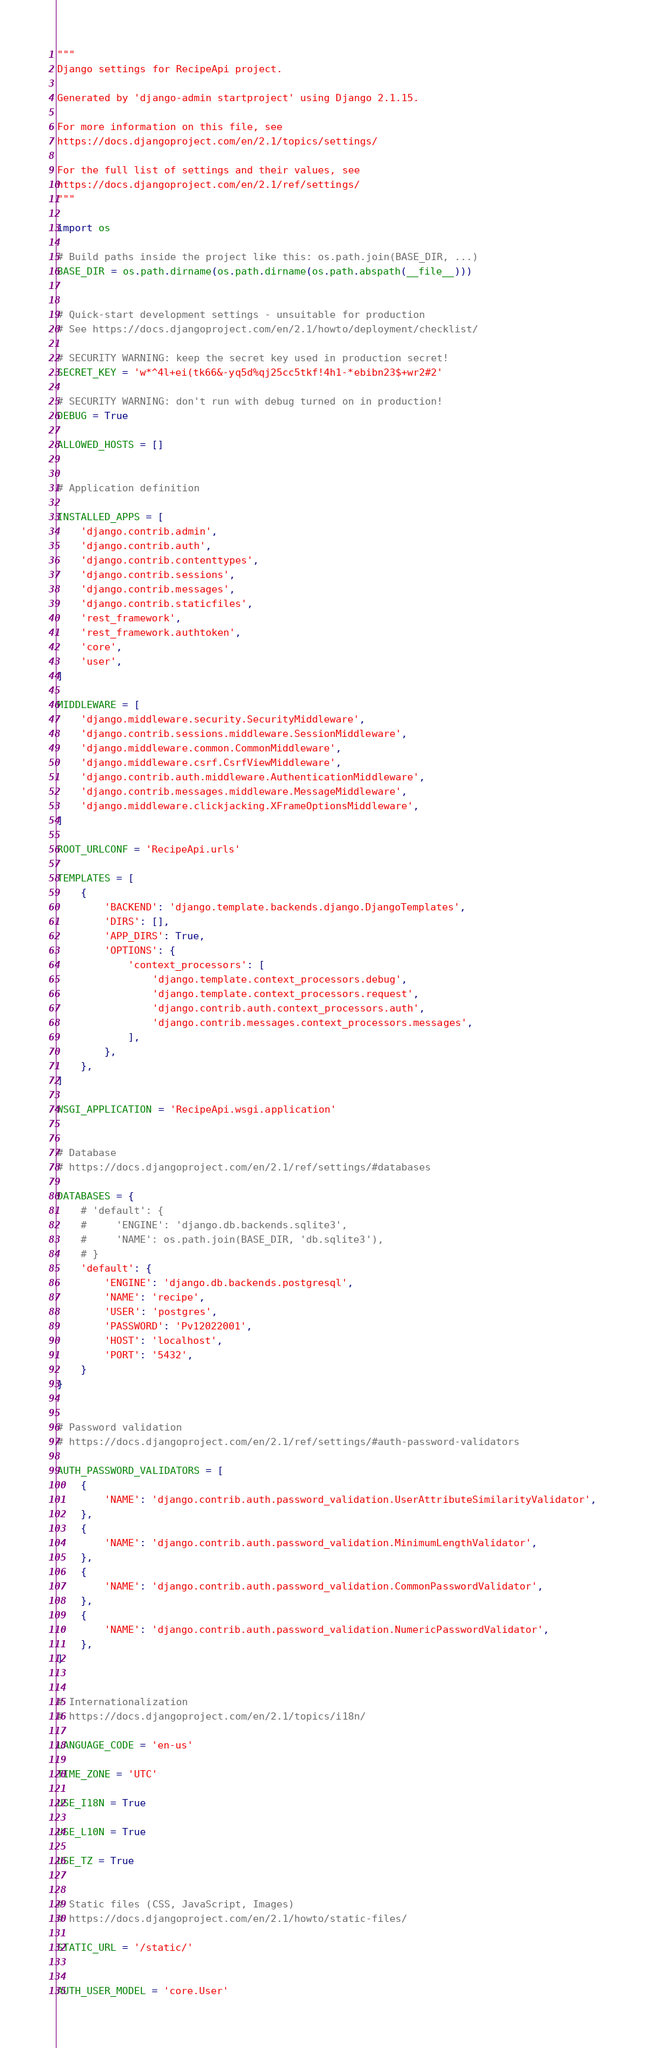<code> <loc_0><loc_0><loc_500><loc_500><_Python_>"""
Django settings for RecipeApi project.

Generated by 'django-admin startproject' using Django 2.1.15.

For more information on this file, see
https://docs.djangoproject.com/en/2.1/topics/settings/

For the full list of settings and their values, see
https://docs.djangoproject.com/en/2.1/ref/settings/
"""

import os

# Build paths inside the project like this: os.path.join(BASE_DIR, ...)
BASE_DIR = os.path.dirname(os.path.dirname(os.path.abspath(__file__)))


# Quick-start development settings - unsuitable for production
# See https://docs.djangoproject.com/en/2.1/howto/deployment/checklist/

# SECURITY WARNING: keep the secret key used in production secret!
SECRET_KEY = 'w*^4l+ei(tk66&-yq5d%qj25cc5tkf!4h1-*ebibn23$+wr2#2'

# SECURITY WARNING: don't run with debug turned on in production!
DEBUG = True

ALLOWED_HOSTS = []


# Application definition

INSTALLED_APPS = [
    'django.contrib.admin',
    'django.contrib.auth',
    'django.contrib.contenttypes',
    'django.contrib.sessions',
    'django.contrib.messages',
    'django.contrib.staticfiles',
    'rest_framework',
    'rest_framework.authtoken',
    'core',
    'user',
]

MIDDLEWARE = [
    'django.middleware.security.SecurityMiddleware',
    'django.contrib.sessions.middleware.SessionMiddleware',
    'django.middleware.common.CommonMiddleware',
    'django.middleware.csrf.CsrfViewMiddleware',
    'django.contrib.auth.middleware.AuthenticationMiddleware',
    'django.contrib.messages.middleware.MessageMiddleware',
    'django.middleware.clickjacking.XFrameOptionsMiddleware',
]

ROOT_URLCONF = 'RecipeApi.urls'

TEMPLATES = [
    {
        'BACKEND': 'django.template.backends.django.DjangoTemplates',
        'DIRS': [],
        'APP_DIRS': True,
        'OPTIONS': {
            'context_processors': [
                'django.template.context_processors.debug',
                'django.template.context_processors.request',
                'django.contrib.auth.context_processors.auth',
                'django.contrib.messages.context_processors.messages',
            ],
        },
    },
]

WSGI_APPLICATION = 'RecipeApi.wsgi.application'


# Database
# https://docs.djangoproject.com/en/2.1/ref/settings/#databases

DATABASES = {
    # 'default': {
    #     'ENGINE': 'django.db.backends.sqlite3',
    #     'NAME': os.path.join(BASE_DIR, 'db.sqlite3'),
    # }
    'default': {
        'ENGINE': 'django.db.backends.postgresql',
        'NAME': 'recipe',
        'USER': 'postgres',
        'PASSWORD': 'Pv12022001',
        'HOST': 'localhost',
        'PORT': '5432',
    }
}


# Password validation
# https://docs.djangoproject.com/en/2.1/ref/settings/#auth-password-validators

AUTH_PASSWORD_VALIDATORS = [
    {
        'NAME': 'django.contrib.auth.password_validation.UserAttributeSimilarityValidator',
    },
    {
        'NAME': 'django.contrib.auth.password_validation.MinimumLengthValidator',
    },
    {
        'NAME': 'django.contrib.auth.password_validation.CommonPasswordValidator',
    },
    {
        'NAME': 'django.contrib.auth.password_validation.NumericPasswordValidator',
    },
]


# Internationalization
# https://docs.djangoproject.com/en/2.1/topics/i18n/

LANGUAGE_CODE = 'en-us'

TIME_ZONE = 'UTC'

USE_I18N = True

USE_L10N = True

USE_TZ = True


# Static files (CSS, JavaScript, Images)
# https://docs.djangoproject.com/en/2.1/howto/static-files/

STATIC_URL = '/static/'


AUTH_USER_MODEL = 'core.User'</code> 